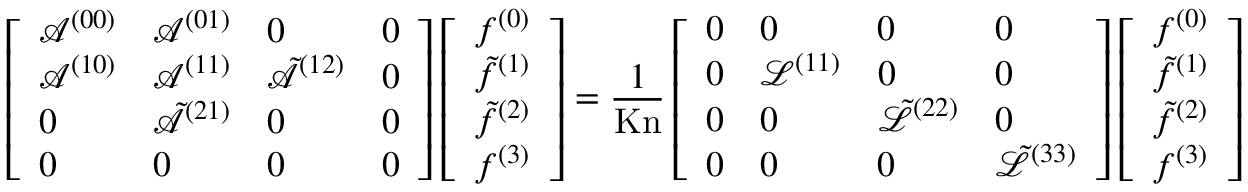Convert formula to latex. <formula><loc_0><loc_0><loc_500><loc_500>\left [ \begin{array} { l l l l } { \mathcal { A } ^ { ( 0 0 ) } } & { \mathcal { A } ^ { ( 0 1 ) } } & { 0 } & { 0 } \\ { \mathcal { A } ^ { ( 1 0 ) } } & { \mathcal { A } ^ { ( 1 1 ) } } & { \tilde { \mathcal { A } } ^ { ( 1 2 ) } } & { 0 } \\ { 0 } & { \tilde { \mathcal { A } } ^ { ( 2 1 ) } } & { 0 } & { 0 } \\ { 0 } & { 0 } & { 0 } & { 0 } \end{array} \right ] \left [ \begin{array} { l } { f ^ { ( 0 ) } } \\ { \tilde { f } ^ { ( 1 ) } } \\ { \tilde { f } ^ { ( 2 ) } } \\ { f ^ { ( 3 ) } } \end{array} \right ] = \frac { 1 } { K n } \left [ \begin{array} { l l l l } { 0 } & { 0 } & { 0 } & { 0 } \\ { 0 } & { \mathcal { L } ^ { ( 1 1 ) } } & { 0 } & { 0 } \\ { 0 } & { 0 } & { \tilde { \mathcal { L } } ^ { ( 2 2 ) } } & { 0 } \\ { 0 } & { 0 } & { 0 } & { \tilde { \mathcal { L } } ^ { ( 3 3 ) } } \end{array} \right ] \left [ \begin{array} { l } { f ^ { ( 0 ) } } \\ { \tilde { f } ^ { ( 1 ) } } \\ { \tilde { f } ^ { ( 2 ) } } \\ { f ^ { ( 3 ) } } \end{array} \right ]</formula> 